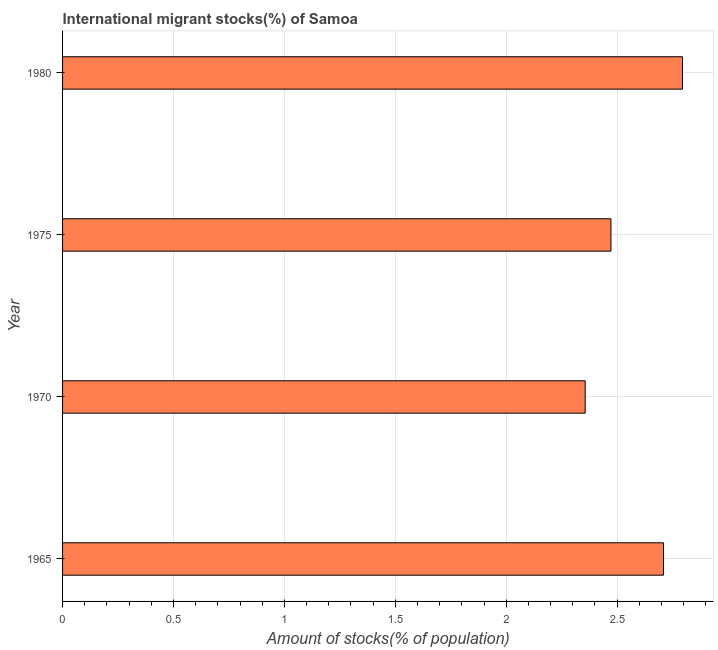Does the graph contain grids?
Offer a terse response. Yes. What is the title of the graph?
Ensure brevity in your answer.  International migrant stocks(%) of Samoa. What is the label or title of the X-axis?
Keep it short and to the point. Amount of stocks(% of population). What is the number of international migrant stocks in 1975?
Your answer should be very brief. 2.47. Across all years, what is the maximum number of international migrant stocks?
Your answer should be compact. 2.79. Across all years, what is the minimum number of international migrant stocks?
Keep it short and to the point. 2.36. In which year was the number of international migrant stocks maximum?
Give a very brief answer. 1980. In which year was the number of international migrant stocks minimum?
Offer a terse response. 1970. What is the sum of the number of international migrant stocks?
Give a very brief answer. 10.33. What is the difference between the number of international migrant stocks in 1965 and 1980?
Make the answer very short. -0.09. What is the average number of international migrant stocks per year?
Make the answer very short. 2.58. What is the median number of international migrant stocks?
Provide a succinct answer. 2.59. In how many years, is the number of international migrant stocks greater than 0.6 %?
Offer a very short reply. 4. Do a majority of the years between 1980 and 1970 (inclusive) have number of international migrant stocks greater than 2.7 %?
Your response must be concise. Yes. What is the ratio of the number of international migrant stocks in 1965 to that in 1980?
Keep it short and to the point. 0.97. What is the difference between the highest and the second highest number of international migrant stocks?
Offer a terse response. 0.09. Is the sum of the number of international migrant stocks in 1975 and 1980 greater than the maximum number of international migrant stocks across all years?
Give a very brief answer. Yes. What is the difference between the highest and the lowest number of international migrant stocks?
Your answer should be compact. 0.44. In how many years, is the number of international migrant stocks greater than the average number of international migrant stocks taken over all years?
Provide a short and direct response. 2. Are all the bars in the graph horizontal?
Your answer should be very brief. Yes. How many years are there in the graph?
Your answer should be very brief. 4. What is the difference between two consecutive major ticks on the X-axis?
Provide a succinct answer. 0.5. Are the values on the major ticks of X-axis written in scientific E-notation?
Offer a very short reply. No. What is the Amount of stocks(% of population) of 1965?
Give a very brief answer. 2.71. What is the Amount of stocks(% of population) of 1970?
Your answer should be compact. 2.36. What is the Amount of stocks(% of population) of 1975?
Ensure brevity in your answer.  2.47. What is the Amount of stocks(% of population) of 1980?
Your response must be concise. 2.79. What is the difference between the Amount of stocks(% of population) in 1965 and 1970?
Give a very brief answer. 0.35. What is the difference between the Amount of stocks(% of population) in 1965 and 1975?
Offer a very short reply. 0.24. What is the difference between the Amount of stocks(% of population) in 1965 and 1980?
Offer a very short reply. -0.09. What is the difference between the Amount of stocks(% of population) in 1970 and 1975?
Ensure brevity in your answer.  -0.12. What is the difference between the Amount of stocks(% of population) in 1970 and 1980?
Your response must be concise. -0.44. What is the difference between the Amount of stocks(% of population) in 1975 and 1980?
Offer a terse response. -0.32. What is the ratio of the Amount of stocks(% of population) in 1965 to that in 1970?
Offer a very short reply. 1.15. What is the ratio of the Amount of stocks(% of population) in 1965 to that in 1975?
Ensure brevity in your answer.  1.1. What is the ratio of the Amount of stocks(% of population) in 1965 to that in 1980?
Make the answer very short. 0.97. What is the ratio of the Amount of stocks(% of population) in 1970 to that in 1975?
Keep it short and to the point. 0.95. What is the ratio of the Amount of stocks(% of population) in 1970 to that in 1980?
Your answer should be very brief. 0.84. What is the ratio of the Amount of stocks(% of population) in 1975 to that in 1980?
Offer a terse response. 0.89. 